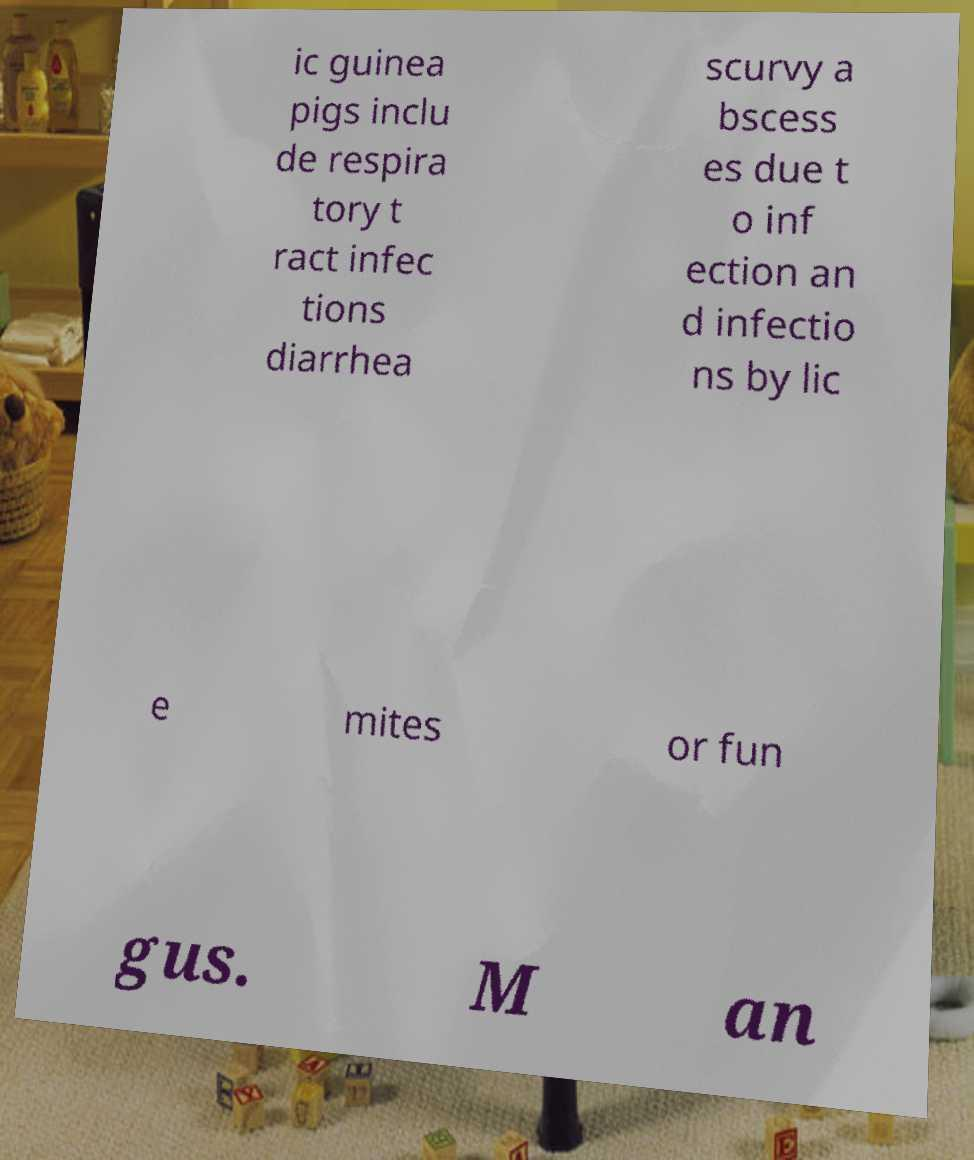Please read and relay the text visible in this image. What does it say? ic guinea pigs inclu de respira tory t ract infec tions diarrhea scurvy a bscess es due t o inf ection an d infectio ns by lic e mites or fun gus. M an 